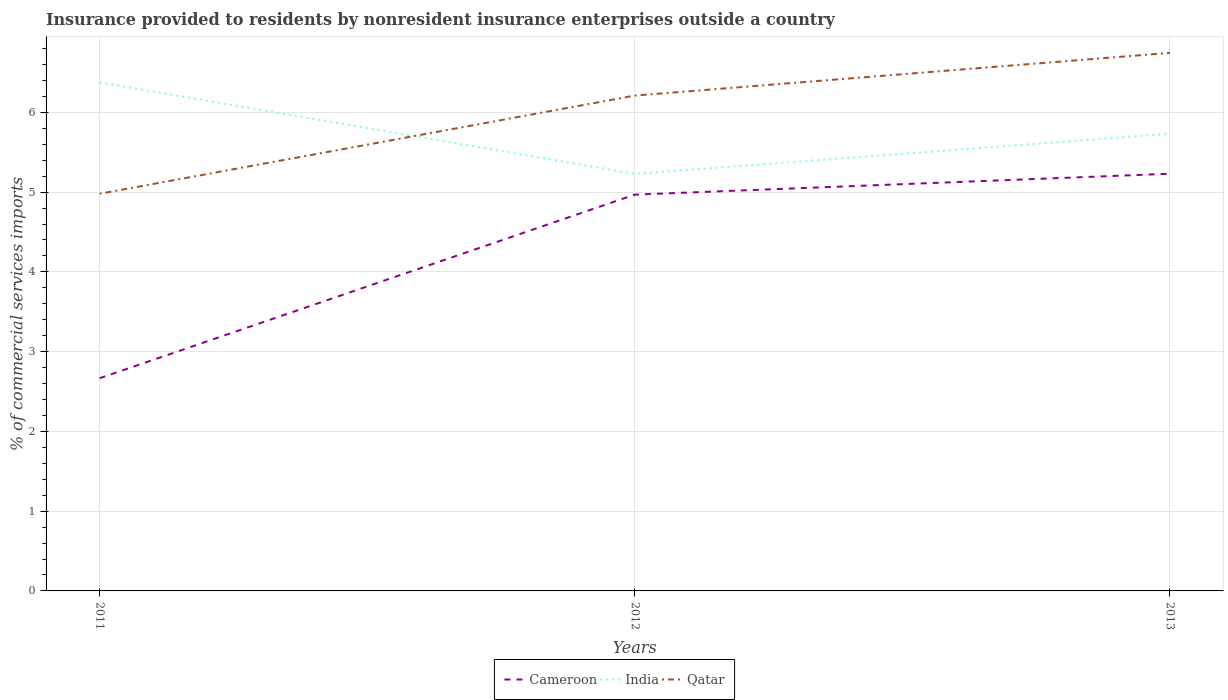Does the line corresponding to India intersect with the line corresponding to Cameroon?
Your response must be concise. No. Across all years, what is the maximum Insurance provided to residents in Qatar?
Ensure brevity in your answer.  4.98. What is the total Insurance provided to residents in Qatar in the graph?
Ensure brevity in your answer.  -1.77. What is the difference between the highest and the second highest Insurance provided to residents in India?
Your response must be concise. 1.15. How many years are there in the graph?
Offer a very short reply. 3. What is the difference between two consecutive major ticks on the Y-axis?
Your response must be concise. 1. Are the values on the major ticks of Y-axis written in scientific E-notation?
Your answer should be very brief. No. Does the graph contain grids?
Ensure brevity in your answer.  Yes. Where does the legend appear in the graph?
Offer a terse response. Bottom center. How are the legend labels stacked?
Give a very brief answer. Horizontal. What is the title of the graph?
Provide a short and direct response. Insurance provided to residents by nonresident insurance enterprises outside a country. What is the label or title of the X-axis?
Keep it short and to the point. Years. What is the label or title of the Y-axis?
Give a very brief answer. % of commercial services imports. What is the % of commercial services imports in Cameroon in 2011?
Your answer should be compact. 2.67. What is the % of commercial services imports of India in 2011?
Offer a terse response. 6.38. What is the % of commercial services imports in Qatar in 2011?
Give a very brief answer. 4.98. What is the % of commercial services imports in Cameroon in 2012?
Give a very brief answer. 4.97. What is the % of commercial services imports in India in 2012?
Offer a very short reply. 5.23. What is the % of commercial services imports in Qatar in 2012?
Keep it short and to the point. 6.21. What is the % of commercial services imports in Cameroon in 2013?
Keep it short and to the point. 5.23. What is the % of commercial services imports in India in 2013?
Keep it short and to the point. 5.73. What is the % of commercial services imports in Qatar in 2013?
Your response must be concise. 6.75. Across all years, what is the maximum % of commercial services imports of Cameroon?
Your response must be concise. 5.23. Across all years, what is the maximum % of commercial services imports in India?
Provide a short and direct response. 6.38. Across all years, what is the maximum % of commercial services imports of Qatar?
Provide a succinct answer. 6.75. Across all years, what is the minimum % of commercial services imports of Cameroon?
Your answer should be compact. 2.67. Across all years, what is the minimum % of commercial services imports of India?
Make the answer very short. 5.23. Across all years, what is the minimum % of commercial services imports in Qatar?
Ensure brevity in your answer.  4.98. What is the total % of commercial services imports of Cameroon in the graph?
Offer a very short reply. 12.87. What is the total % of commercial services imports in India in the graph?
Provide a succinct answer. 17.34. What is the total % of commercial services imports of Qatar in the graph?
Provide a short and direct response. 17.94. What is the difference between the % of commercial services imports in Cameroon in 2011 and that in 2012?
Your answer should be compact. -2.3. What is the difference between the % of commercial services imports of India in 2011 and that in 2012?
Provide a short and direct response. 1.15. What is the difference between the % of commercial services imports in Qatar in 2011 and that in 2012?
Provide a succinct answer. -1.23. What is the difference between the % of commercial services imports in Cameroon in 2011 and that in 2013?
Your answer should be very brief. -2.56. What is the difference between the % of commercial services imports in India in 2011 and that in 2013?
Offer a very short reply. 0.64. What is the difference between the % of commercial services imports in Qatar in 2011 and that in 2013?
Provide a short and direct response. -1.77. What is the difference between the % of commercial services imports in Cameroon in 2012 and that in 2013?
Provide a succinct answer. -0.26. What is the difference between the % of commercial services imports of India in 2012 and that in 2013?
Make the answer very short. -0.5. What is the difference between the % of commercial services imports in Qatar in 2012 and that in 2013?
Provide a succinct answer. -0.54. What is the difference between the % of commercial services imports in Cameroon in 2011 and the % of commercial services imports in India in 2012?
Keep it short and to the point. -2.56. What is the difference between the % of commercial services imports in Cameroon in 2011 and the % of commercial services imports in Qatar in 2012?
Keep it short and to the point. -3.54. What is the difference between the % of commercial services imports in India in 2011 and the % of commercial services imports in Qatar in 2012?
Your response must be concise. 0.17. What is the difference between the % of commercial services imports of Cameroon in 2011 and the % of commercial services imports of India in 2013?
Your answer should be very brief. -3.07. What is the difference between the % of commercial services imports in Cameroon in 2011 and the % of commercial services imports in Qatar in 2013?
Your answer should be very brief. -4.08. What is the difference between the % of commercial services imports in India in 2011 and the % of commercial services imports in Qatar in 2013?
Provide a succinct answer. -0.37. What is the difference between the % of commercial services imports in Cameroon in 2012 and the % of commercial services imports in India in 2013?
Ensure brevity in your answer.  -0.76. What is the difference between the % of commercial services imports of Cameroon in 2012 and the % of commercial services imports of Qatar in 2013?
Offer a terse response. -1.78. What is the difference between the % of commercial services imports of India in 2012 and the % of commercial services imports of Qatar in 2013?
Provide a succinct answer. -1.52. What is the average % of commercial services imports in Cameroon per year?
Provide a succinct answer. 4.29. What is the average % of commercial services imports in India per year?
Provide a succinct answer. 5.78. What is the average % of commercial services imports in Qatar per year?
Provide a succinct answer. 5.98. In the year 2011, what is the difference between the % of commercial services imports in Cameroon and % of commercial services imports in India?
Keep it short and to the point. -3.71. In the year 2011, what is the difference between the % of commercial services imports in Cameroon and % of commercial services imports in Qatar?
Provide a short and direct response. -2.31. In the year 2011, what is the difference between the % of commercial services imports of India and % of commercial services imports of Qatar?
Provide a succinct answer. 1.4. In the year 2012, what is the difference between the % of commercial services imports of Cameroon and % of commercial services imports of India?
Keep it short and to the point. -0.26. In the year 2012, what is the difference between the % of commercial services imports of Cameroon and % of commercial services imports of Qatar?
Make the answer very short. -1.24. In the year 2012, what is the difference between the % of commercial services imports of India and % of commercial services imports of Qatar?
Keep it short and to the point. -0.98. In the year 2013, what is the difference between the % of commercial services imports in Cameroon and % of commercial services imports in India?
Offer a very short reply. -0.5. In the year 2013, what is the difference between the % of commercial services imports of Cameroon and % of commercial services imports of Qatar?
Provide a succinct answer. -1.52. In the year 2013, what is the difference between the % of commercial services imports in India and % of commercial services imports in Qatar?
Provide a succinct answer. -1.01. What is the ratio of the % of commercial services imports of Cameroon in 2011 to that in 2012?
Give a very brief answer. 0.54. What is the ratio of the % of commercial services imports of India in 2011 to that in 2012?
Provide a short and direct response. 1.22. What is the ratio of the % of commercial services imports of Qatar in 2011 to that in 2012?
Your answer should be very brief. 0.8. What is the ratio of the % of commercial services imports in Cameroon in 2011 to that in 2013?
Your answer should be very brief. 0.51. What is the ratio of the % of commercial services imports of India in 2011 to that in 2013?
Your answer should be very brief. 1.11. What is the ratio of the % of commercial services imports in Qatar in 2011 to that in 2013?
Give a very brief answer. 0.74. What is the ratio of the % of commercial services imports in Cameroon in 2012 to that in 2013?
Your response must be concise. 0.95. What is the ratio of the % of commercial services imports of India in 2012 to that in 2013?
Offer a terse response. 0.91. What is the ratio of the % of commercial services imports of Qatar in 2012 to that in 2013?
Offer a terse response. 0.92. What is the difference between the highest and the second highest % of commercial services imports in Cameroon?
Make the answer very short. 0.26. What is the difference between the highest and the second highest % of commercial services imports of India?
Your answer should be compact. 0.64. What is the difference between the highest and the second highest % of commercial services imports in Qatar?
Ensure brevity in your answer.  0.54. What is the difference between the highest and the lowest % of commercial services imports of Cameroon?
Make the answer very short. 2.56. What is the difference between the highest and the lowest % of commercial services imports in India?
Make the answer very short. 1.15. What is the difference between the highest and the lowest % of commercial services imports in Qatar?
Offer a very short reply. 1.77. 